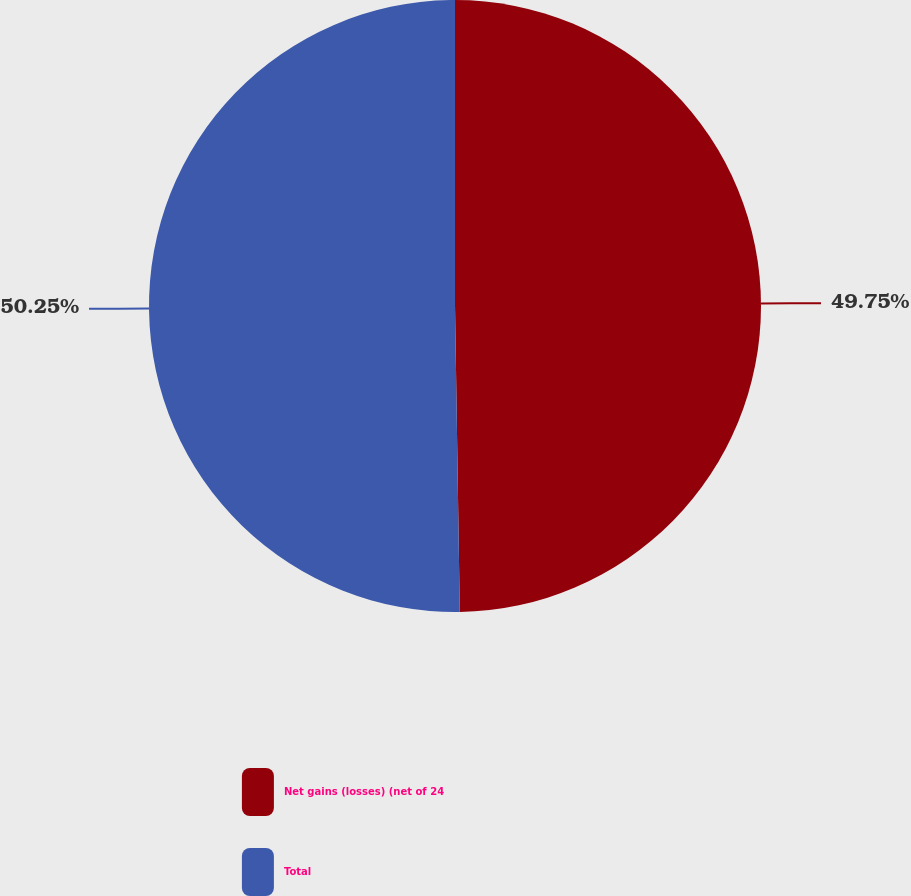<chart> <loc_0><loc_0><loc_500><loc_500><pie_chart><fcel>Net gains (losses) (net of 24<fcel>Total<nl><fcel>49.75%<fcel>50.25%<nl></chart> 